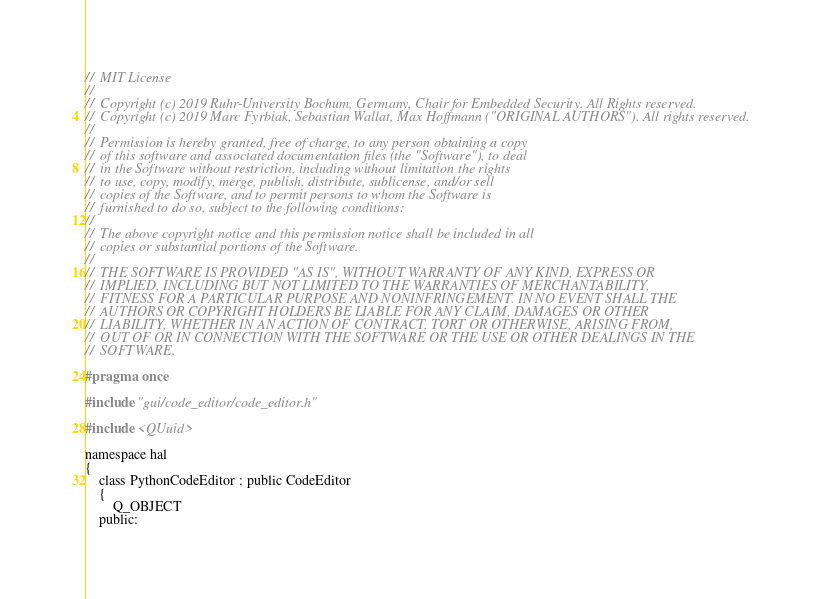<code> <loc_0><loc_0><loc_500><loc_500><_C_>//  MIT License
//
//  Copyright (c) 2019 Ruhr-University Bochum, Germany, Chair for Embedded Security. All Rights reserved.
//  Copyright (c) 2019 Marc Fyrbiak, Sebastian Wallat, Max Hoffmann ("ORIGINAL AUTHORS"). All rights reserved.
//
//  Permission is hereby granted, free of charge, to any person obtaining a copy
//  of this software and associated documentation files (the "Software"), to deal
//  in the Software without restriction, including without limitation the rights
//  to use, copy, modify, merge, publish, distribute, sublicense, and/or sell
//  copies of the Software, and to permit persons to whom the Software is
//  furnished to do so, subject to the following conditions:
//
//  The above copyright notice and this permission notice shall be included in all
//  copies or substantial portions of the Software.
//
//  THE SOFTWARE IS PROVIDED "AS IS", WITHOUT WARRANTY OF ANY KIND, EXPRESS OR
//  IMPLIED, INCLUDING BUT NOT LIMITED TO THE WARRANTIES OF MERCHANTABILITY,
//  FITNESS FOR A PARTICULAR PURPOSE AND NONINFRINGEMENT. IN NO EVENT SHALL THE
//  AUTHORS OR COPYRIGHT HOLDERS BE LIABLE FOR ANY CLAIM, DAMAGES OR OTHER
//  LIABILITY, WHETHER IN AN ACTION OF CONTRACT, TORT OR OTHERWISE, ARISING FROM,
//  OUT OF OR IN CONNECTION WITH THE SOFTWARE OR THE USE OR OTHER DEALINGS IN THE
//  SOFTWARE.

#pragma once

#include "gui/code_editor/code_editor.h"

#include <QUuid>

namespace hal
{
    class PythonCodeEditor : public CodeEditor
    {
        Q_OBJECT
    public:</code> 